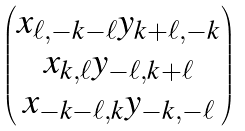Convert formula to latex. <formula><loc_0><loc_0><loc_500><loc_500>\begin{pmatrix} x _ { \ell , - k - \ell } y _ { k + \ell , - k } \\ x _ { k , \ell } y _ { - \ell , k + \ell } \\ x _ { - k - \ell , k } y _ { - k , - \ell } \\ \end{pmatrix}</formula> 